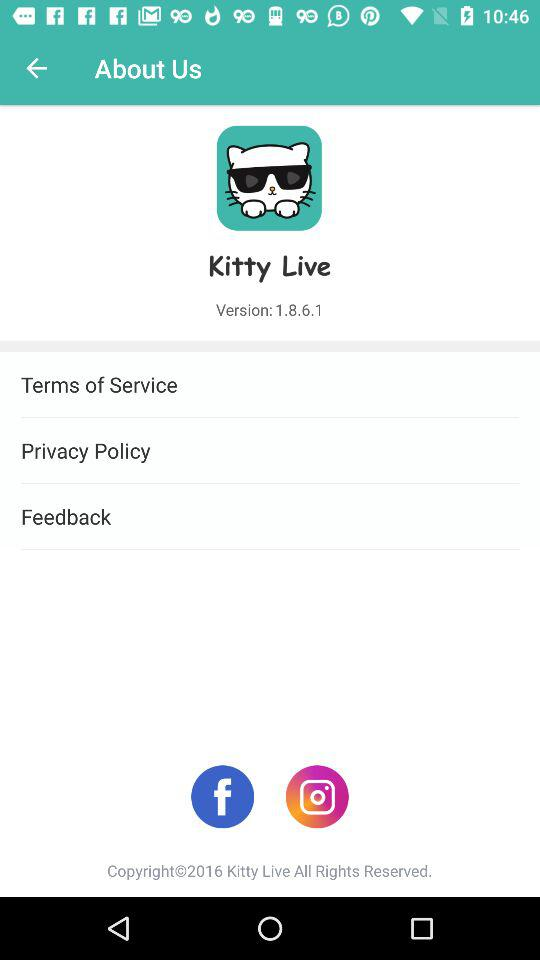What is the name of the application? The name of the application is "Kitty Live". 